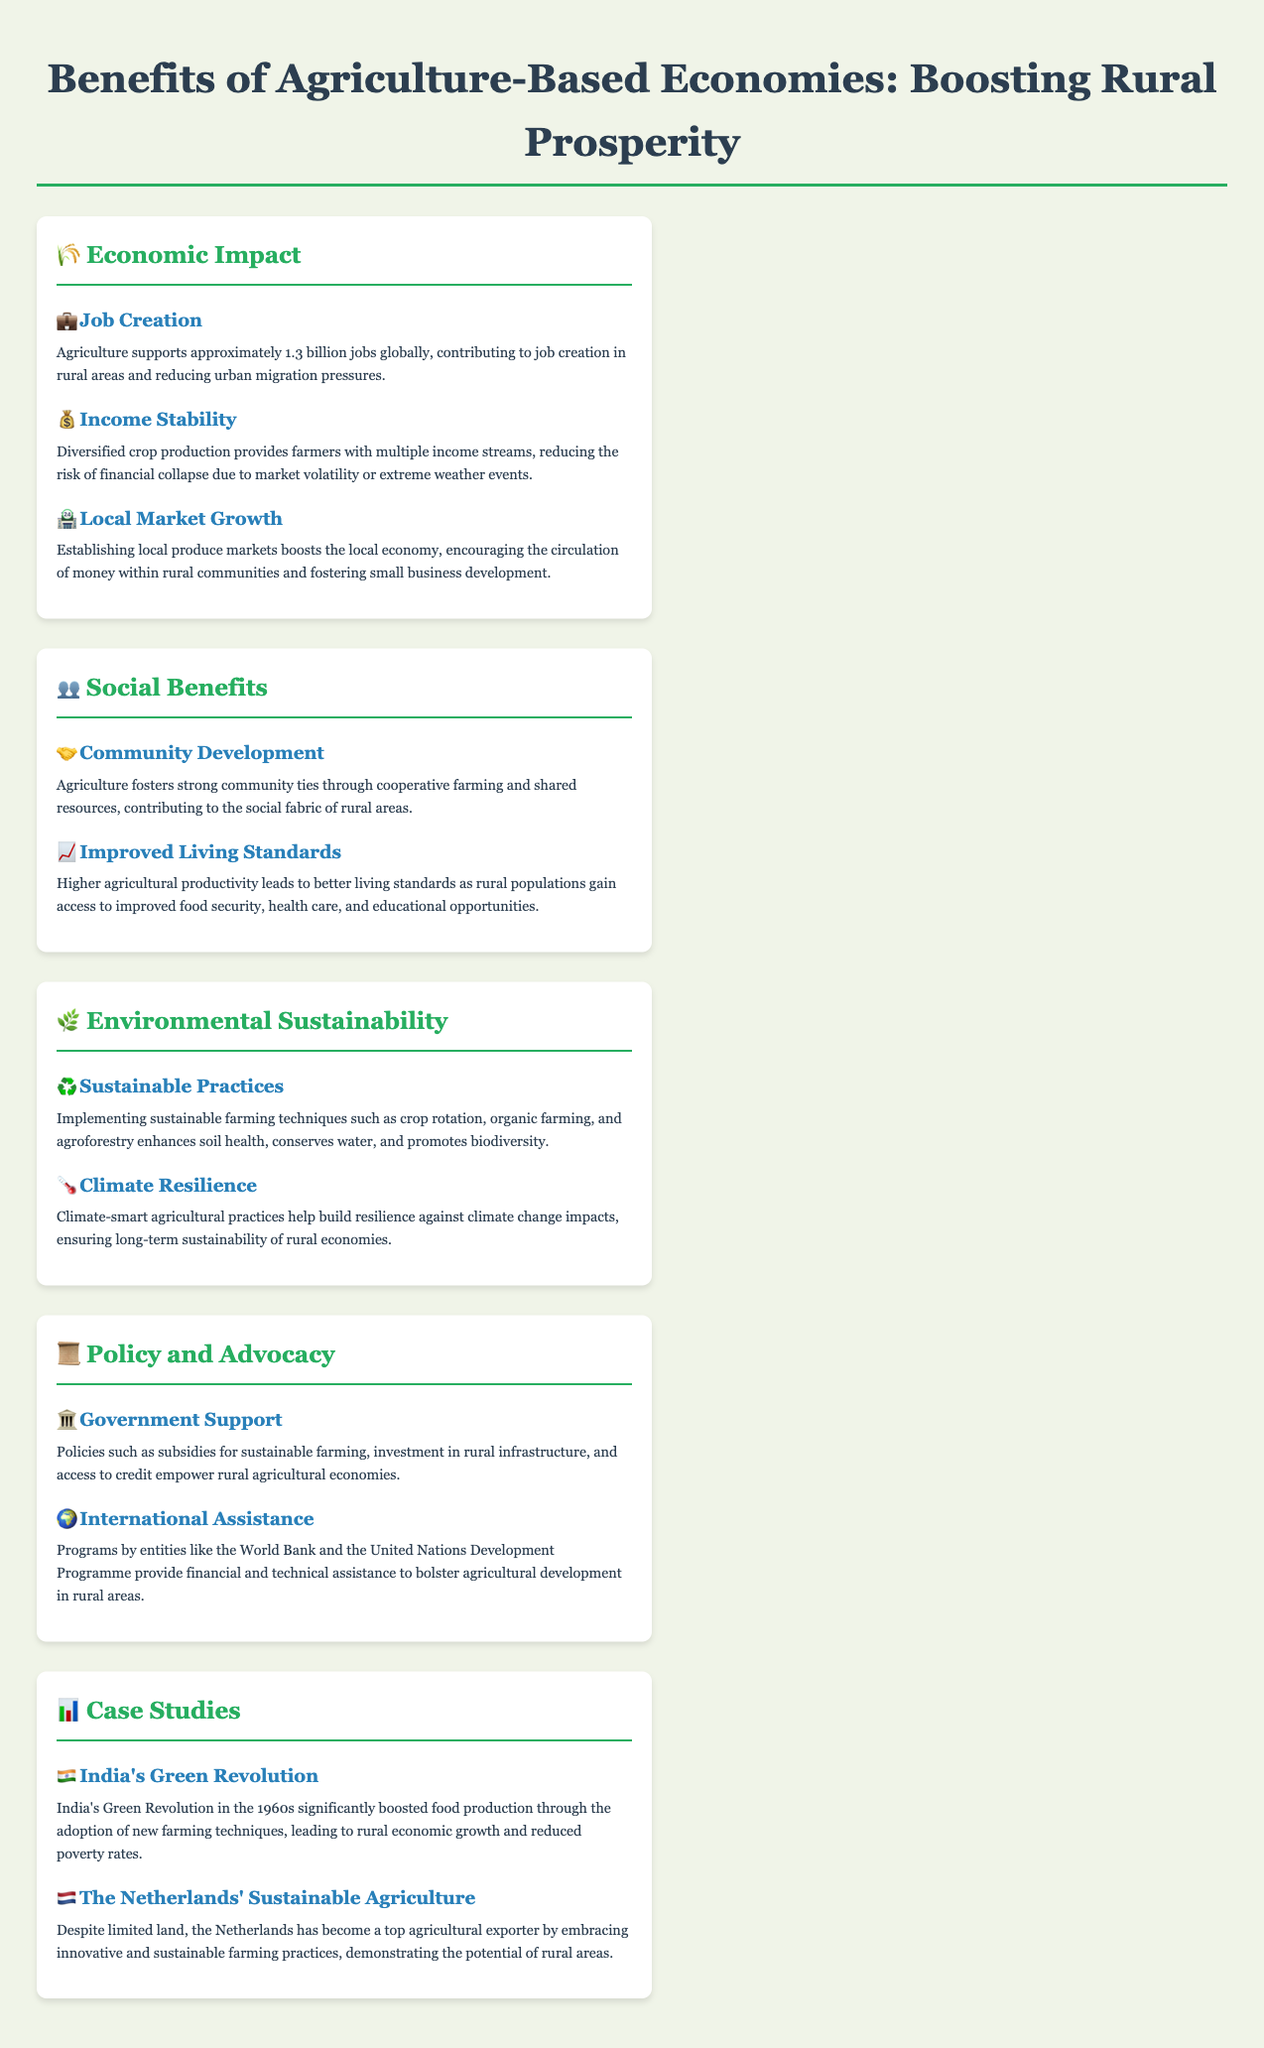what is the global job support from agriculture? Agriculture supports approximately 1.3 billion jobs globally.
Answer: 1.3 billion what two economic advantages are mentioned for rural areas? The document mentions job creation and income stability as economic advantages for rural areas.
Answer: Job Creation, Income Stability what practice helps enhance soil health? Implementing sustainable farming techniques such as crop rotation, organic farming, and agroforestry enhances soil health.
Answer: Sustainable farming techniques what type of policy empowers rural agricultural economies? Policies such as subsidies for sustainable farming, investment in rural infrastructure, and access to credit empower rural agricultural economies.
Answer: Government Support how did India's Green Revolution affect rural economic growth? India's Green Revolution significantly boosted food production leading to rural economic growth and reduced poverty rates.
Answer: Boosted food production what is one social benefit of agriculture? Agriculture fosters strong community ties through cooperative farming and shared resources.
Answer: Community Ties which country is noted for its sustainable agriculture despite limited land? The Netherlands is noted for its sustainable agriculture despite limited land.
Answer: The Netherlands what are climate-smart agricultural practices aimed at? Climate-smart agricultural practices are aimed at building resilience against climate change impacts.
Answer: Building resilience against climate change how many case studies are presented in the document? The document presents two case studies in the "Case Studies" section.
Answer: Two 